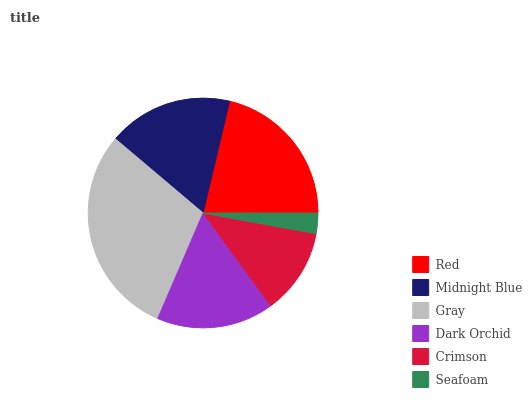Is Seafoam the minimum?
Answer yes or no. Yes. Is Gray the maximum?
Answer yes or no. Yes. Is Midnight Blue the minimum?
Answer yes or no. No. Is Midnight Blue the maximum?
Answer yes or no. No. Is Red greater than Midnight Blue?
Answer yes or no. Yes. Is Midnight Blue less than Red?
Answer yes or no. Yes. Is Midnight Blue greater than Red?
Answer yes or no. No. Is Red less than Midnight Blue?
Answer yes or no. No. Is Midnight Blue the high median?
Answer yes or no. Yes. Is Dark Orchid the low median?
Answer yes or no. Yes. Is Red the high median?
Answer yes or no. No. Is Seafoam the low median?
Answer yes or no. No. 